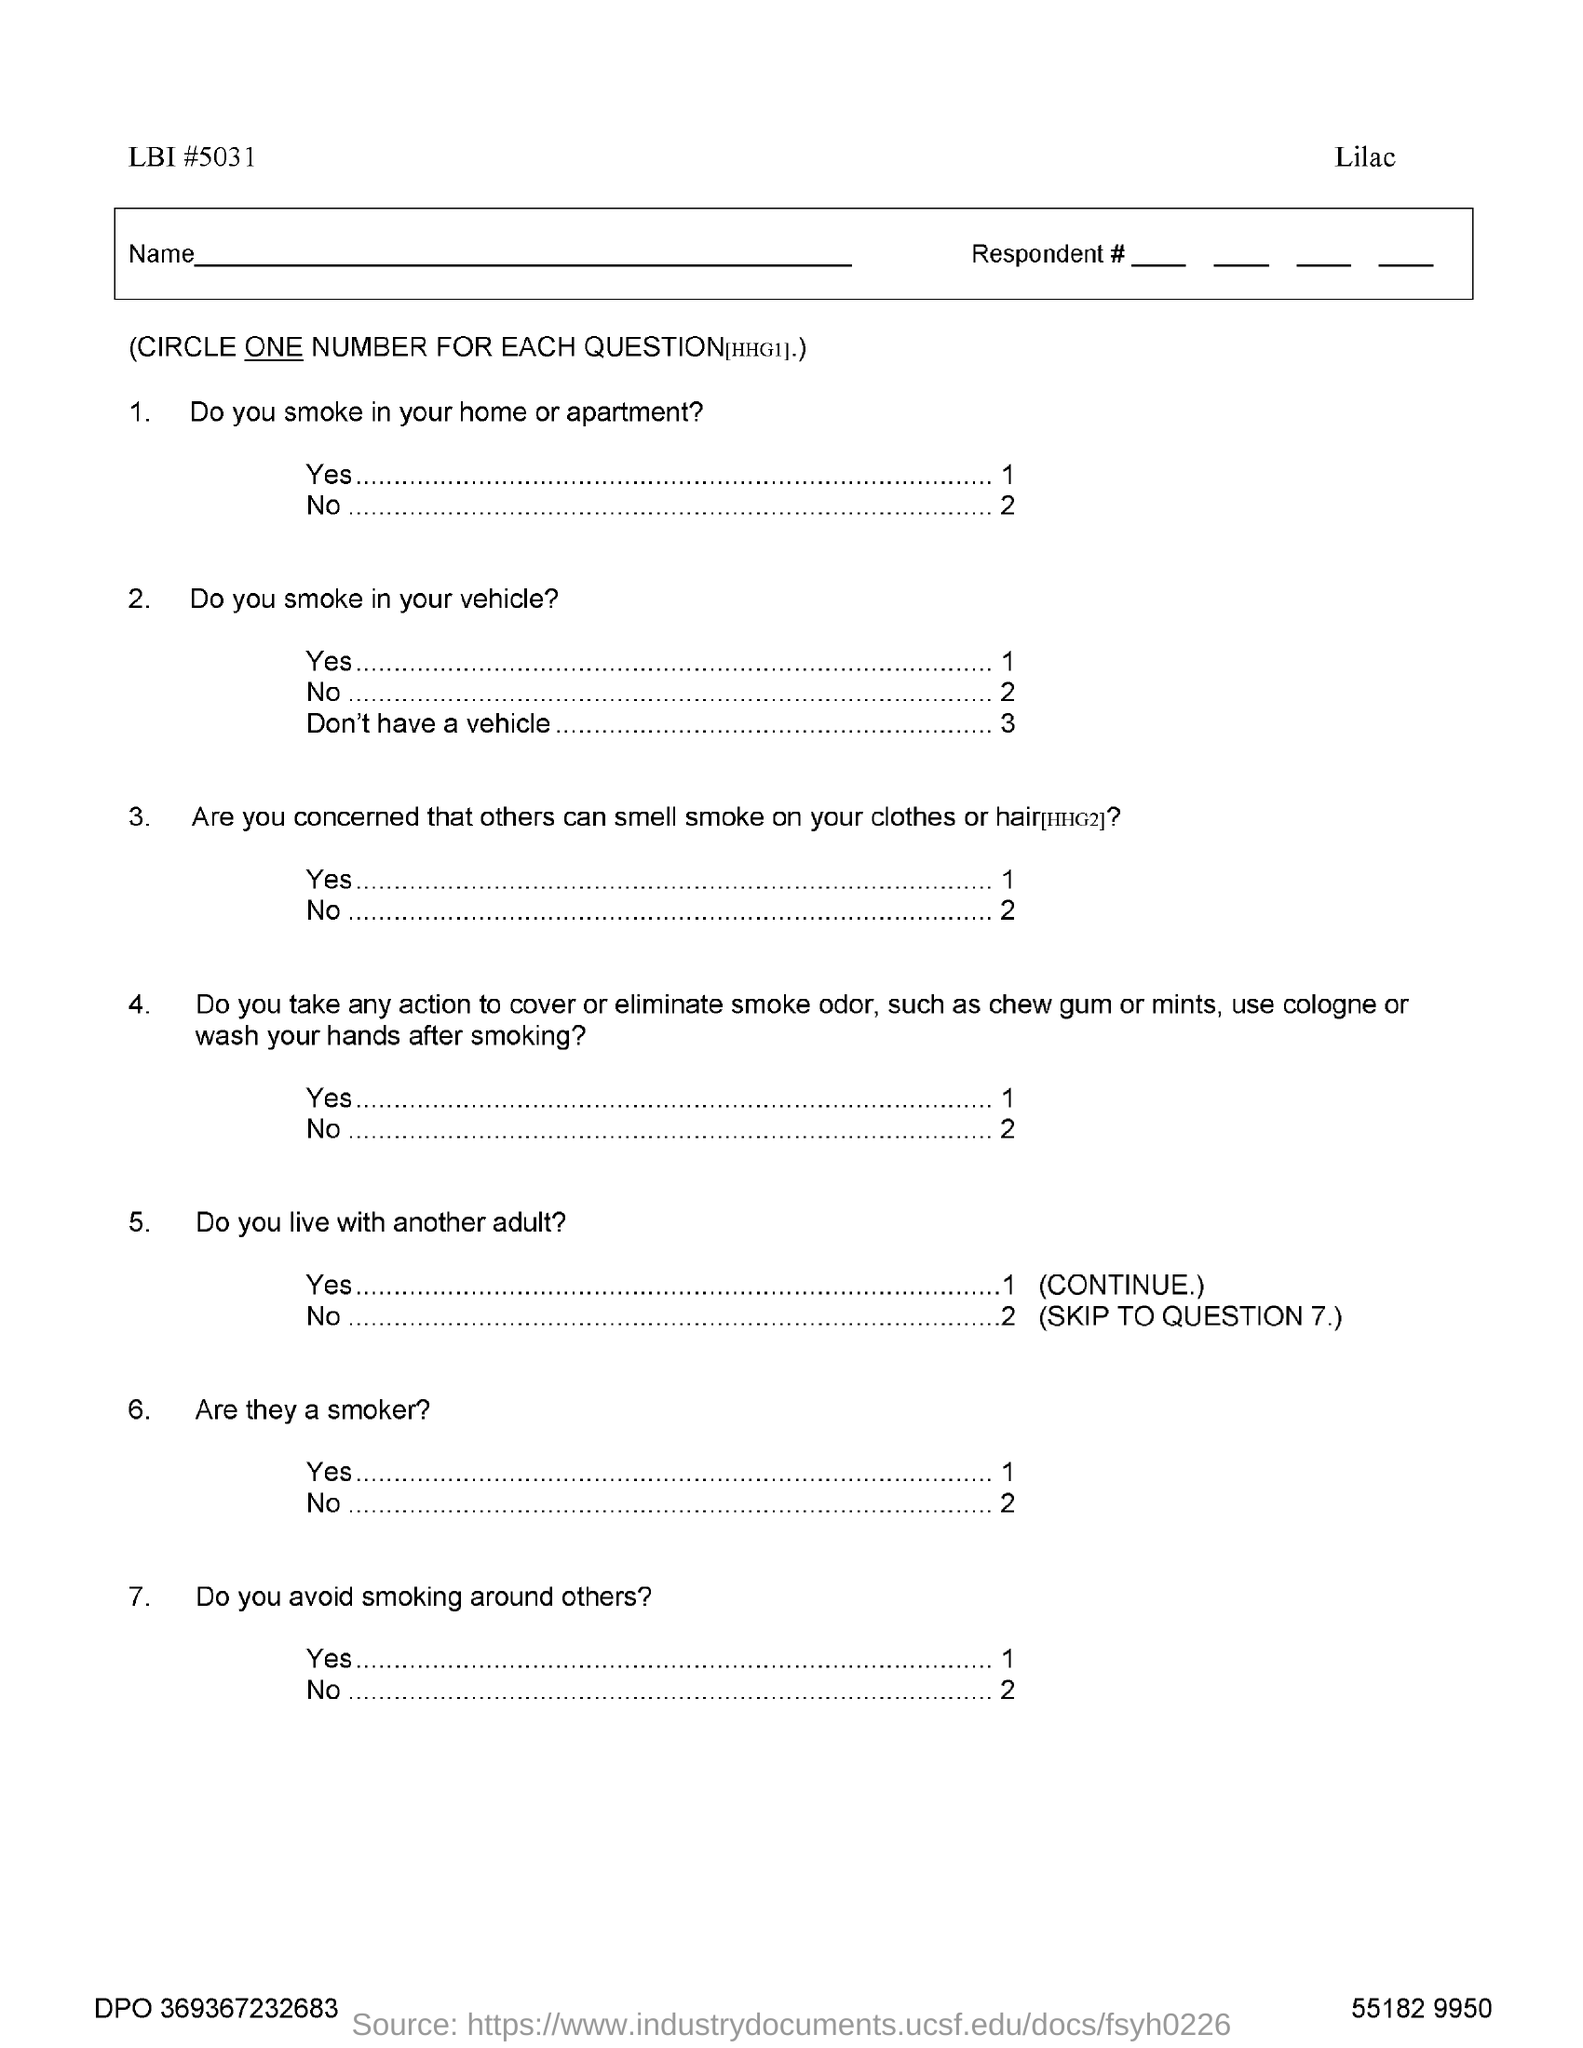List a handful of essential elements in this visual. The LBI number is 5031. 